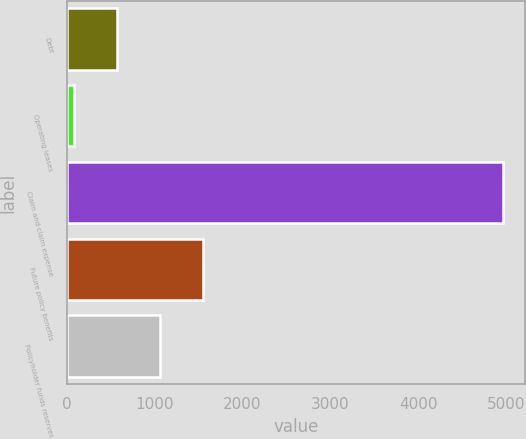Convert chart. <chart><loc_0><loc_0><loc_500><loc_500><bar_chart><fcel>Debt<fcel>Operating leases<fcel>Claim and claim expense<fcel>Future policy benefits<fcel>Policyholder funds reserves<nl><fcel>570.52<fcel>81.8<fcel>4969<fcel>1547.96<fcel>1059.24<nl></chart> 